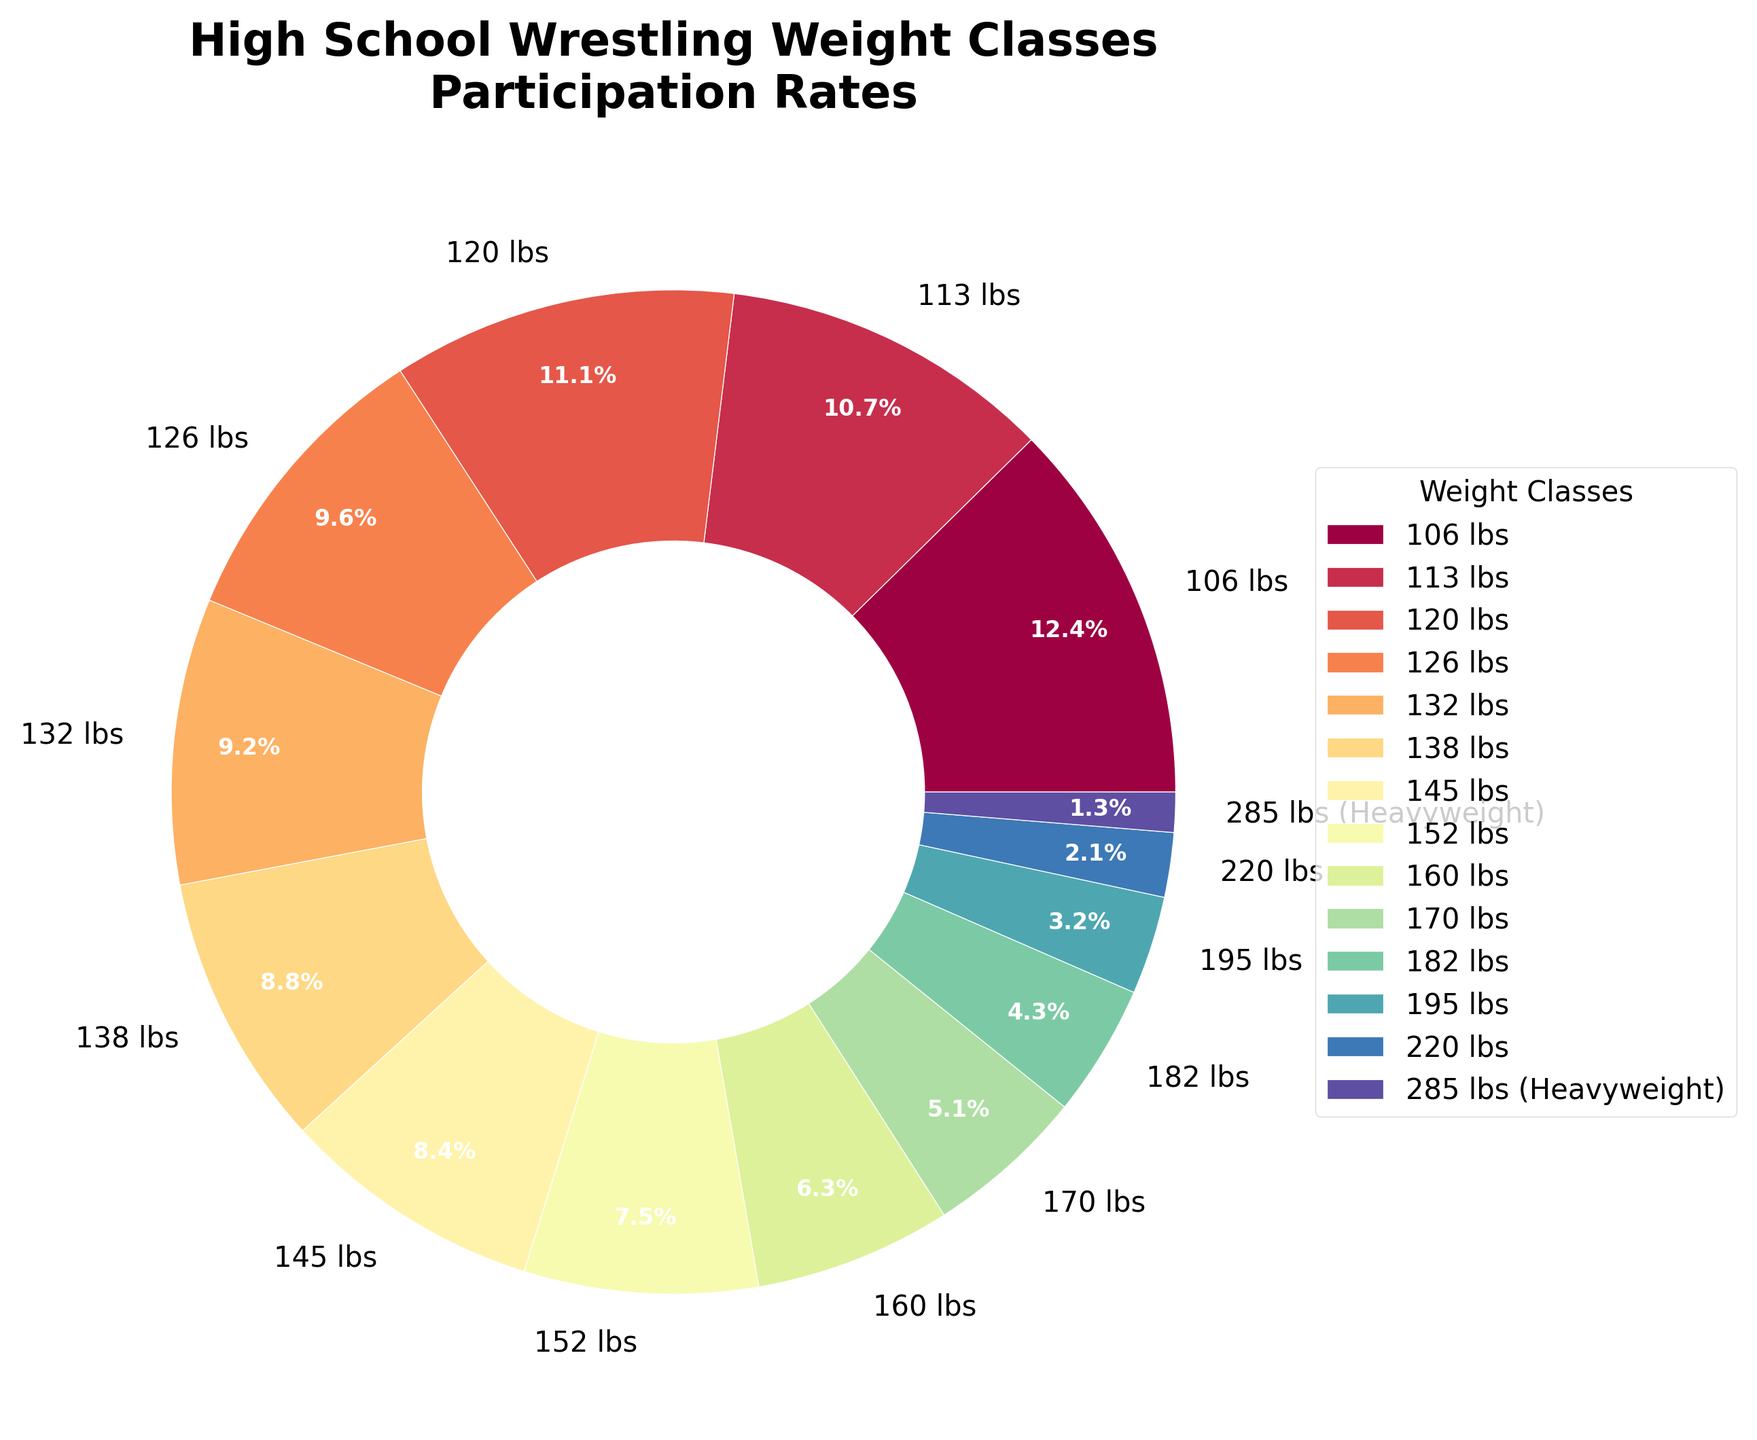Which weight class has the highest participation rate? To find the highest participation rate, look for the largest slice in the pie chart. The 106 lbs weight class has the most significant percentage.
Answer: 106 lbs Compare the participation rates of the 113 lbs and 195 lbs weight classes. Which is higher? First, identify the participation rates of the 113 lbs (10.8%) and the 195 lbs (3.2%) weight classes from the pie chart. 10.8% is greater than 3.2%.
Answer: 113 lbs What is the total participation rate for the weight classes above 160 lbs? Sum the participation rates for the weight classes: 170 lbs (5.2%), 182 lbs (4.3%), 195 lbs (3.2%), 220 lbs (2.1%), and 285 lbs (1.3%). The total is 5.2 + 4.3 + 3.2 + 2.1 + 1.3 = 16.1%.
Answer: 16.1% Is the participation rate for the 120 lbs weight class more or less than 10%? The 120 lbs weight class has a participation rate of 11.2%. This is greater than 10%.
Answer: More Which two weight classes have the smallest and largest participation rates? Identify the smallest slice and the largest slice in the pie chart. The smallest is the 285 lbs (1.3%), and the largest is the 106 lbs (12.5%).
Answer: 285 lbs and 106 lbs What is the difference in participation rates between the 152 lbs and 145 lbs weight classes? Find the rates for 152 lbs (7.6%) and 145 lbs (8.5%), then subtract: 8.5% - 7.6% = 0.9%.
Answer: 0.9% Which weight class has almost the same participation rate as the 160 lbs weight class? Look for slices similar in size to the 160 lbs (6.4%) class. The 170 lbs class (5.2%) is close but not exact.
Answer: None Do the combined participation rates of the 138 lbs and 132 lbs weight classes exceed 20%? Sum the participation rates for 138 lbs (8.9%) and 132 lbs (9.3%). The total is 8.9% + 9.3% = 18.2%, which is less than 20%.
Answer: No By how much does the participation rate of the 106 lbs exceed the combined rate of the 220 lbs and 285 lbs classes? The 106 lbs class has a rate of 12.5%. Combine the rates for 220 lbs (2.1%) and 285 lbs (1.3%): 2.1 + 1.3 = 3.4%. Subtract 3.4 from 12.5: 12.5 - 3.4 = 9.1%.
Answer: 9.1% 